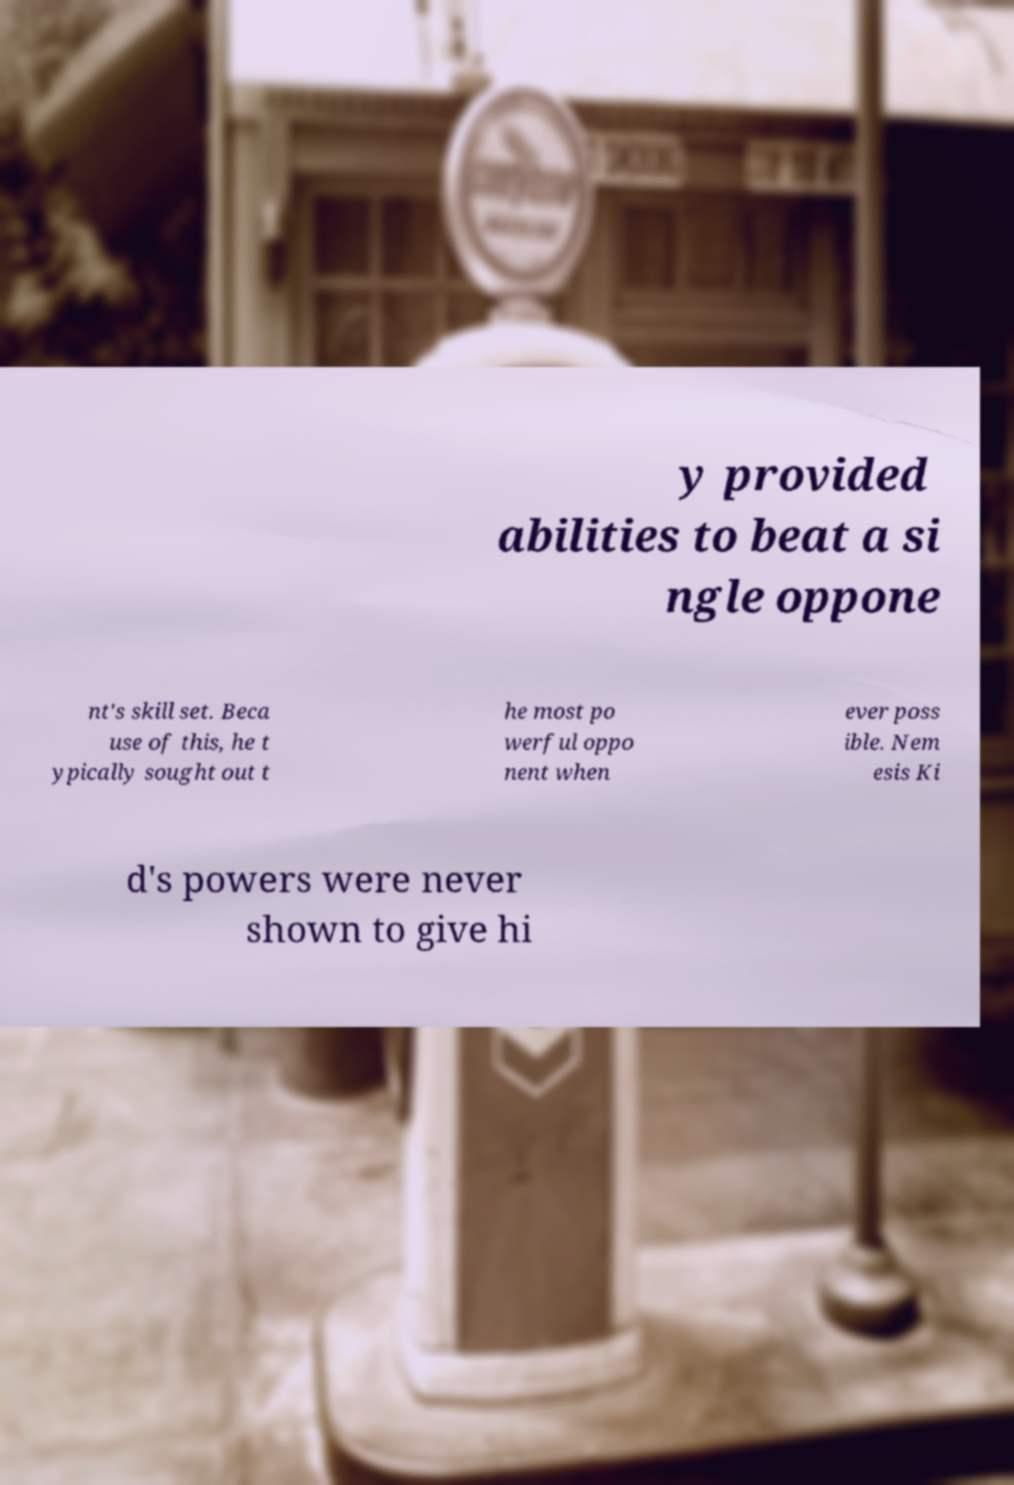Can you read and provide the text displayed in the image?This photo seems to have some interesting text. Can you extract and type it out for me? y provided abilities to beat a si ngle oppone nt's skill set. Beca use of this, he t ypically sought out t he most po werful oppo nent when ever poss ible. Nem esis Ki d's powers were never shown to give hi 